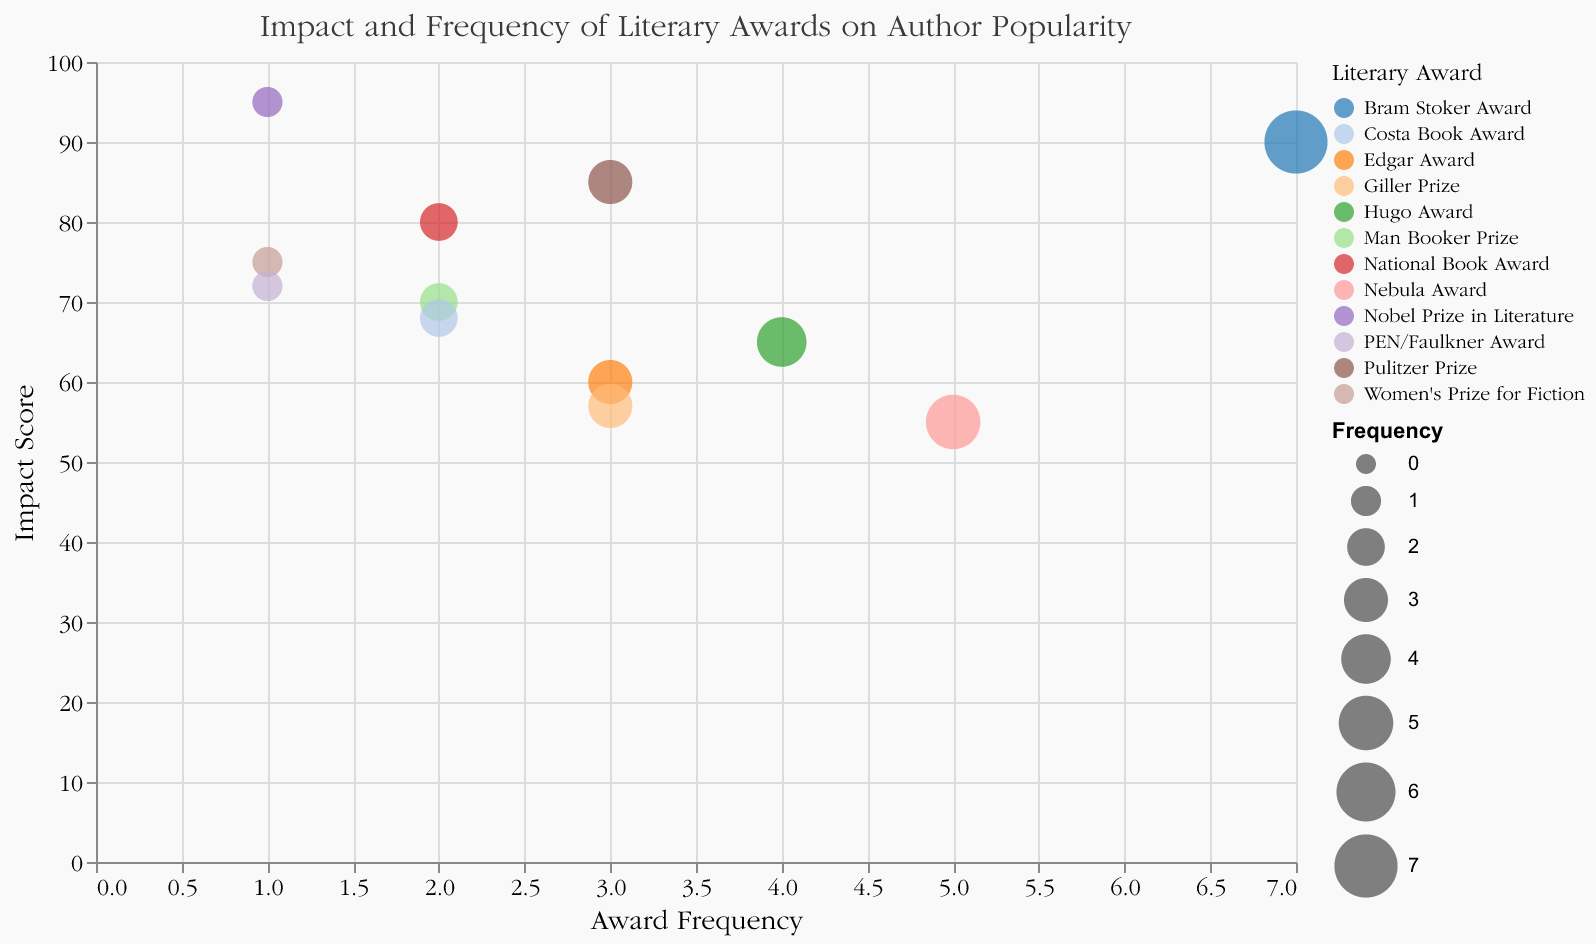What is the title of the Bubble Chart? The title of the chart is located at the top and it describes the overall purpose of the visualization.
Answer: Impact and Frequency of Literary Awards on Author Popularity Which author has the highest Impact Score? The Impact Score is displayed on the Y-axis, and the author with the highest point on this axis has the highest score. In the visual legend, you can match the bubble color to the author.
Answer: Gabriel García Márquez Which award has the highest frequency? The frequency is displayed on the X-axis, and the largest bubble farthest to the right on this axis represents the award with the highest frequency. The visual legend matches the bubble's color to the award.
Answer: Bram Stoker Award What is the average Impact Score of awards with a frequency of 1? Identify the bubbles with a frequency of 1, which includes Nobel Prize in Literature, Women's Prize for Fiction, and PEN/Faulkner Award. Sum their Impact Scores (95 + 75 + 72) and divide by 3 to find the average.
Answer: 80.67 Which award has both a high Impact Score and high frequency? Look for bubbles with a large size (indicating high Frequency) and a high placement on the Y-axis (indicating high Impact Score). The Bram Stoker Award has both high frequency (7) and high Impact Score (90).
Answer: Bram Stoker Award Between the Hugo Award and the Edgar Award, which has a higher Impact Score? Compare the Y-axis positions of the bubbles corresponding to the Hugo Award and the Edgar Award. The Hugo Award has an Impact Score of 65, while the Edgar Award has a score of 60.
Answer: Hugo Award Is there a significant relationship between Frequency and Impact Score? To determine a significant relationship, observe the general trend of the bubbles. If higher frequencies generally align with higher Impact Scores, or vice versa, there might be a correlation.
Answer: No clear relationship observed How often has Neil Gaiman received the Hugo Award? Refer to the visual legend for the Hugo Award and see the size and position of the corresponding bubble on the X-axis to identify frequency.
Answer: 4 times What is the combined frequency of the Man Booker Prize and National Book Award? Find the frequencies of the Man Booker Prize (2) and the National Book Award (2) and add them together to get the combined frequency.
Answer: 4 Which author associated with a frequency of two has the highest Impact Score? Identify authors with a frequency value of 2: Margaret Atwood, Colson Whitehead, and Hilary Mantel. Compare their Impact Scores using the Y-axis values.
Answer: Colson Whitehead 